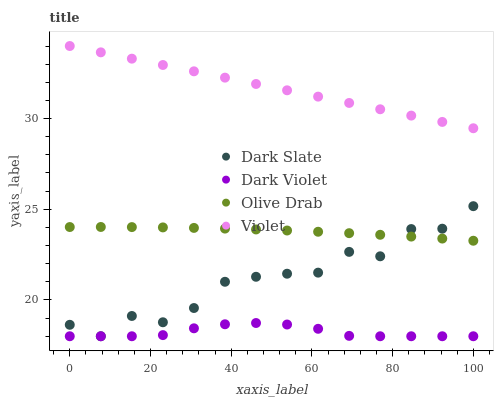Does Dark Violet have the minimum area under the curve?
Answer yes or no. Yes. Does Violet have the maximum area under the curve?
Answer yes or no. Yes. Does Olive Drab have the minimum area under the curve?
Answer yes or no. No. Does Olive Drab have the maximum area under the curve?
Answer yes or no. No. Is Violet the smoothest?
Answer yes or no. Yes. Is Dark Slate the roughest?
Answer yes or no. Yes. Is Olive Drab the smoothest?
Answer yes or no. No. Is Olive Drab the roughest?
Answer yes or no. No. Does Dark Slate have the lowest value?
Answer yes or no. Yes. Does Olive Drab have the lowest value?
Answer yes or no. No. Does Violet have the highest value?
Answer yes or no. Yes. Does Olive Drab have the highest value?
Answer yes or no. No. Is Olive Drab less than Violet?
Answer yes or no. Yes. Is Violet greater than Olive Drab?
Answer yes or no. Yes. Does Olive Drab intersect Dark Slate?
Answer yes or no. Yes. Is Olive Drab less than Dark Slate?
Answer yes or no. No. Is Olive Drab greater than Dark Slate?
Answer yes or no. No. Does Olive Drab intersect Violet?
Answer yes or no. No. 